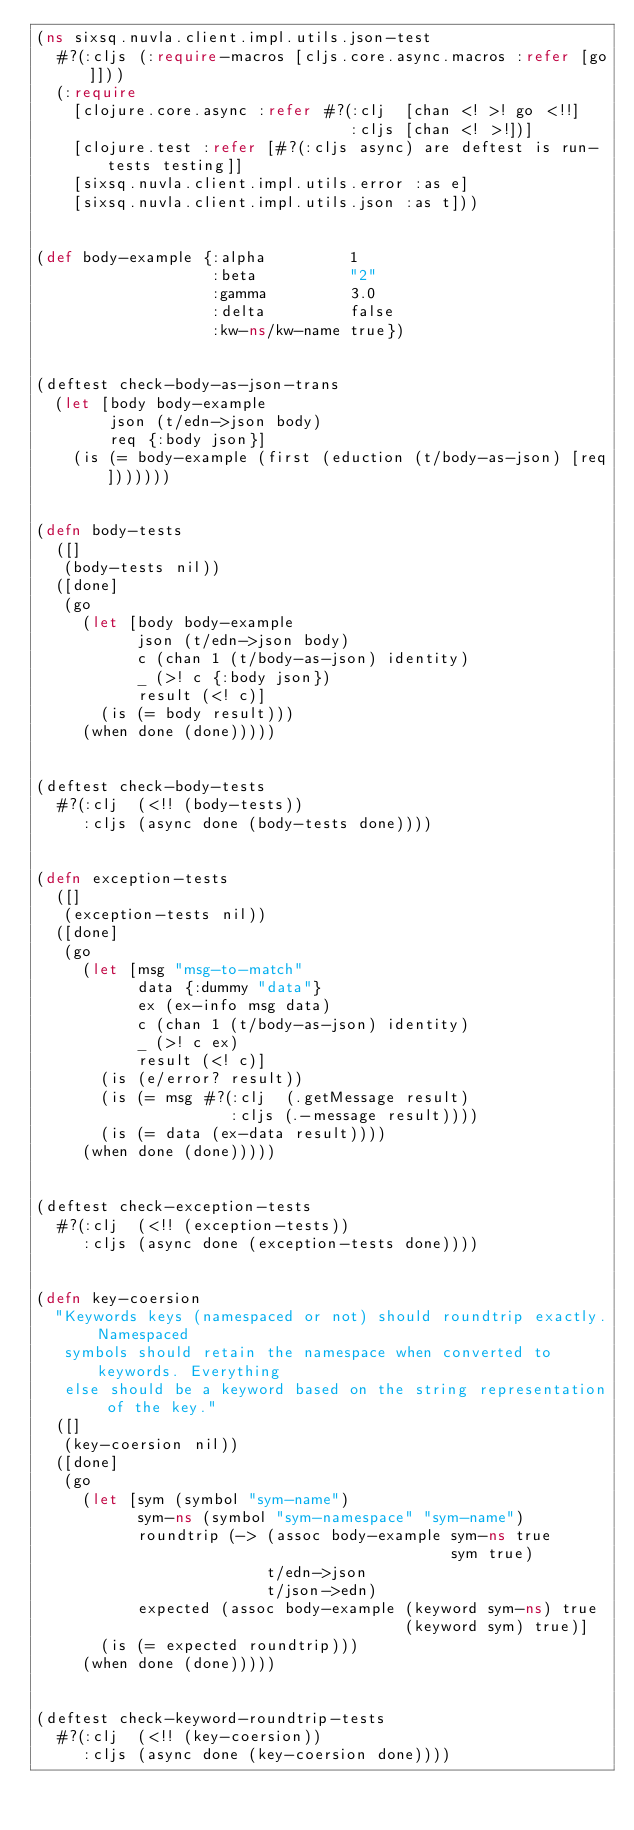Convert code to text. <code><loc_0><loc_0><loc_500><loc_500><_Clojure_>(ns sixsq.nuvla.client.impl.utils.json-test
  #?(:cljs (:require-macros [cljs.core.async.macros :refer [go]]))
  (:require
    [clojure.core.async :refer #?(:clj  [chan <! >! go <!!]
                                  :cljs [chan <! >!])]
    [clojure.test :refer [#?(:cljs async) are deftest is run-tests testing]]
    [sixsq.nuvla.client.impl.utils.error :as e]
    [sixsq.nuvla.client.impl.utils.json :as t]))


(def body-example {:alpha         1
                   :beta          "2"
                   :gamma         3.0
                   :delta         false
                   :kw-ns/kw-name true})


(deftest check-body-as-json-trans
  (let [body body-example
        json (t/edn->json body)
        req {:body json}]
    (is (= body-example (first (eduction (t/body-as-json) [req]))))))


(defn body-tests
  ([]
   (body-tests nil))
  ([done]
   (go
     (let [body body-example
           json (t/edn->json body)
           c (chan 1 (t/body-as-json) identity)
           _ (>! c {:body json})
           result (<! c)]
       (is (= body result)))
     (when done (done)))))


(deftest check-body-tests
  #?(:clj  (<!! (body-tests))
     :cljs (async done (body-tests done))))


(defn exception-tests
  ([]
   (exception-tests nil))
  ([done]
   (go
     (let [msg "msg-to-match"
           data {:dummy "data"}
           ex (ex-info msg data)
           c (chan 1 (t/body-as-json) identity)
           _ (>! c ex)
           result (<! c)]
       (is (e/error? result))
       (is (= msg #?(:clj  (.getMessage result)
                     :cljs (.-message result))))
       (is (= data (ex-data result))))
     (when done (done)))))


(deftest check-exception-tests
  #?(:clj  (<!! (exception-tests))
     :cljs (async done (exception-tests done))))


(defn key-coersion
  "Keywords keys (namespaced or not) should roundtrip exactly. Namespaced
   symbols should retain the namespace when converted to keywords. Everything
   else should be a keyword based on the string representation of the key."
  ([]
   (key-coersion nil))
  ([done]
   (go
     (let [sym (symbol "sym-name")
           sym-ns (symbol "sym-namespace" "sym-name")
           roundtrip (-> (assoc body-example sym-ns true
                                             sym true)
                         t/edn->json
                         t/json->edn)
           expected (assoc body-example (keyword sym-ns) true
                                        (keyword sym) true)]
       (is (= expected roundtrip)))
     (when done (done)))))


(deftest check-keyword-roundtrip-tests
  #?(:clj  (<!! (key-coersion))
     :cljs (async done (key-coersion done))))
</code> 